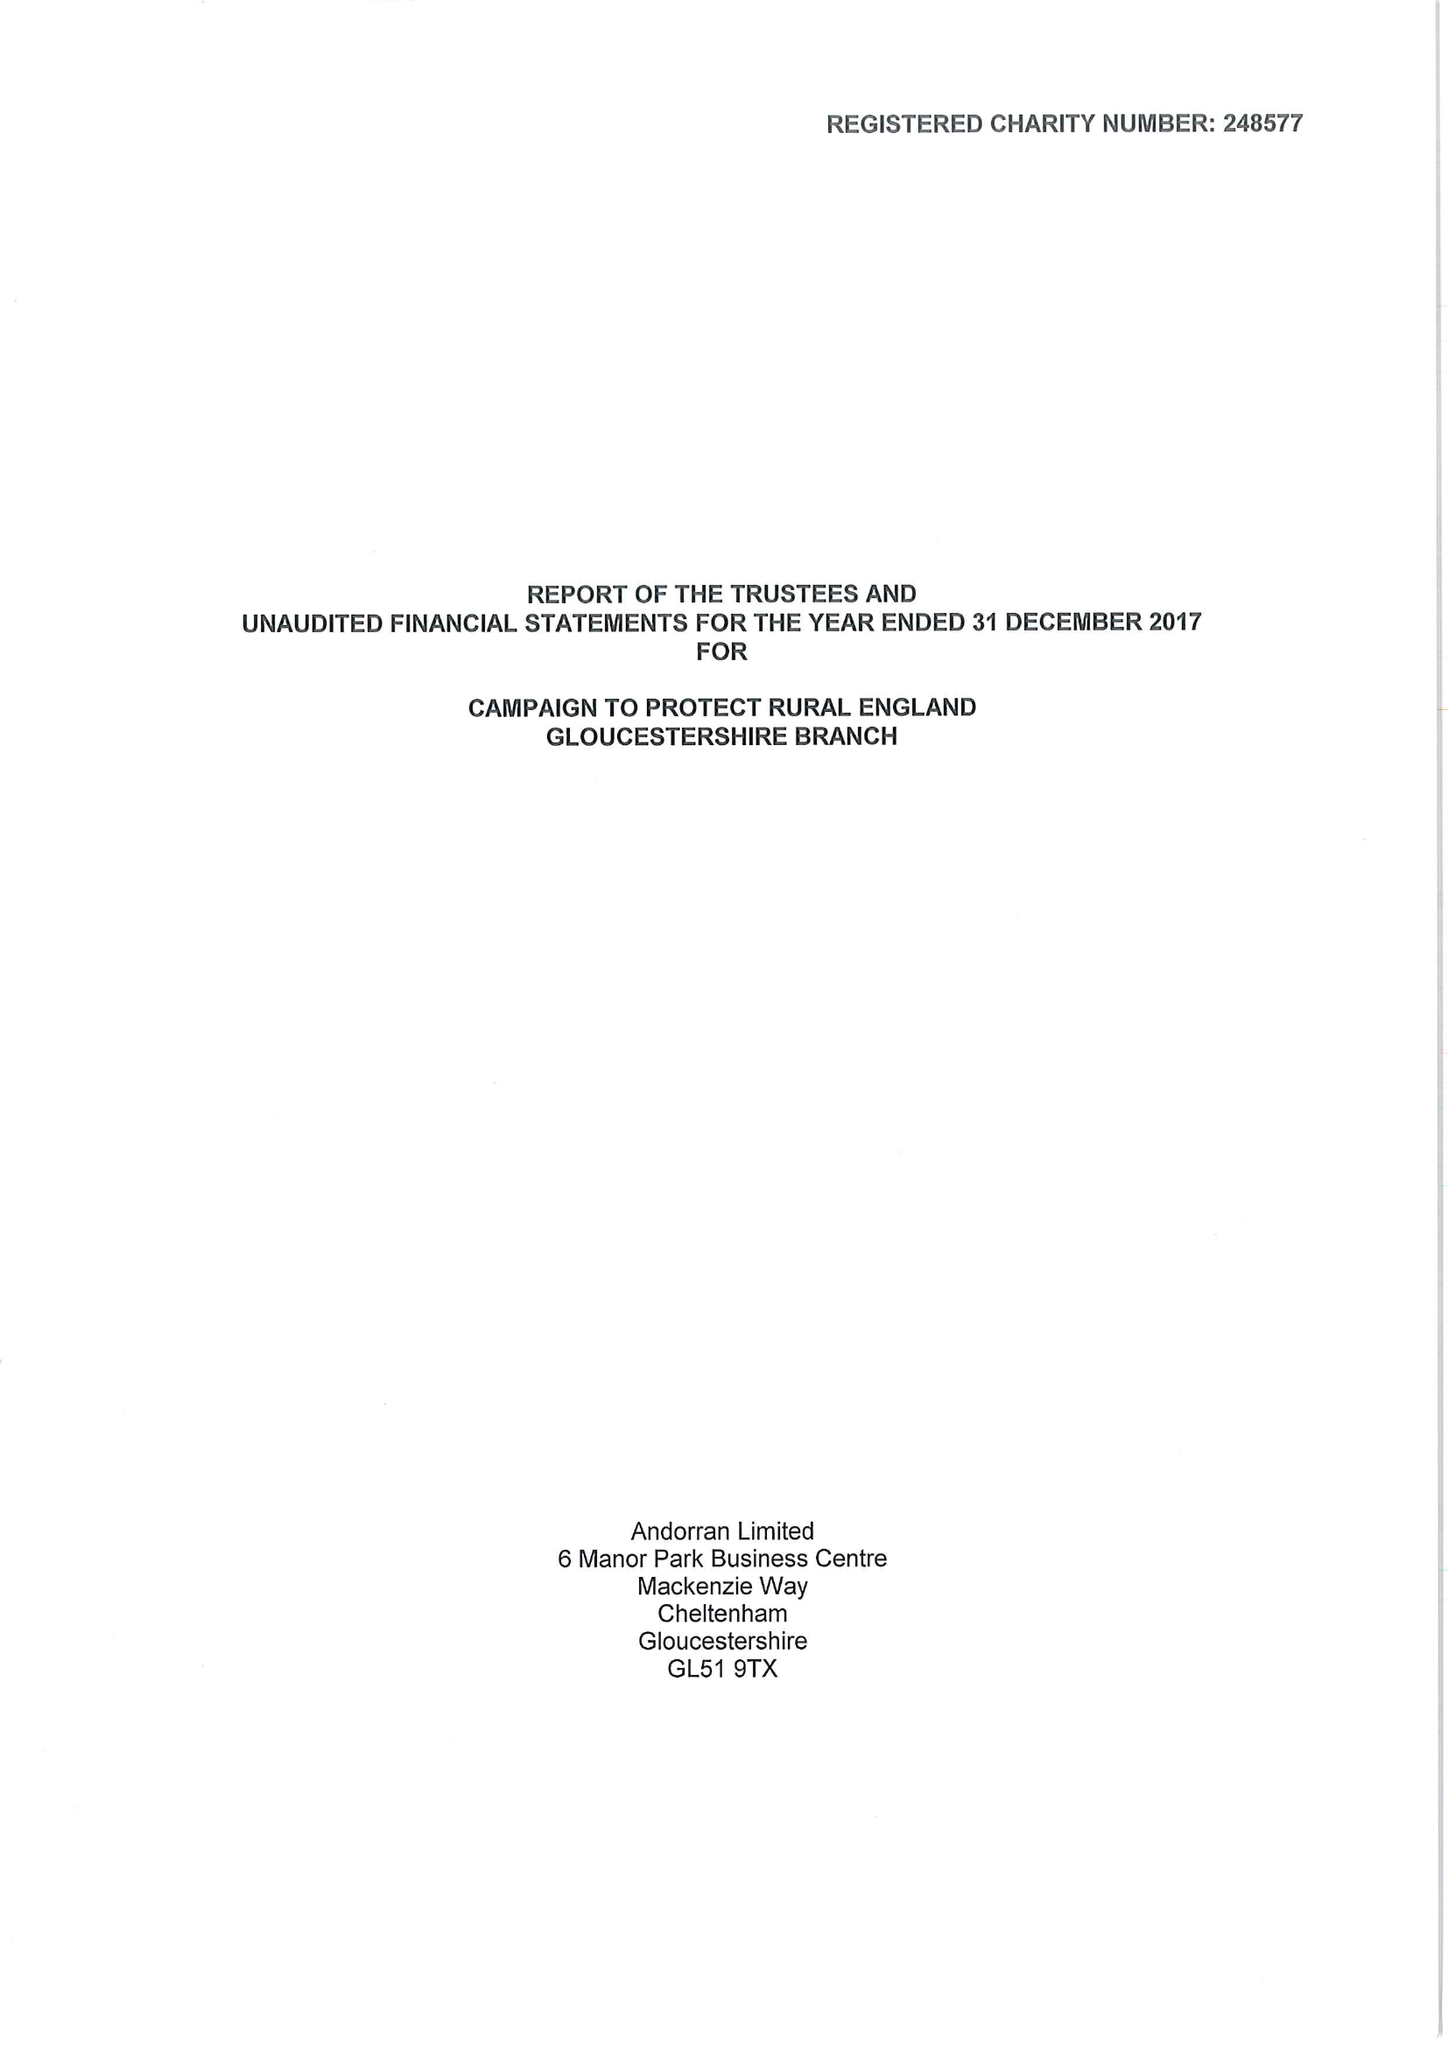What is the value for the report_date?
Answer the question using a single word or phrase. 2017-12-31 